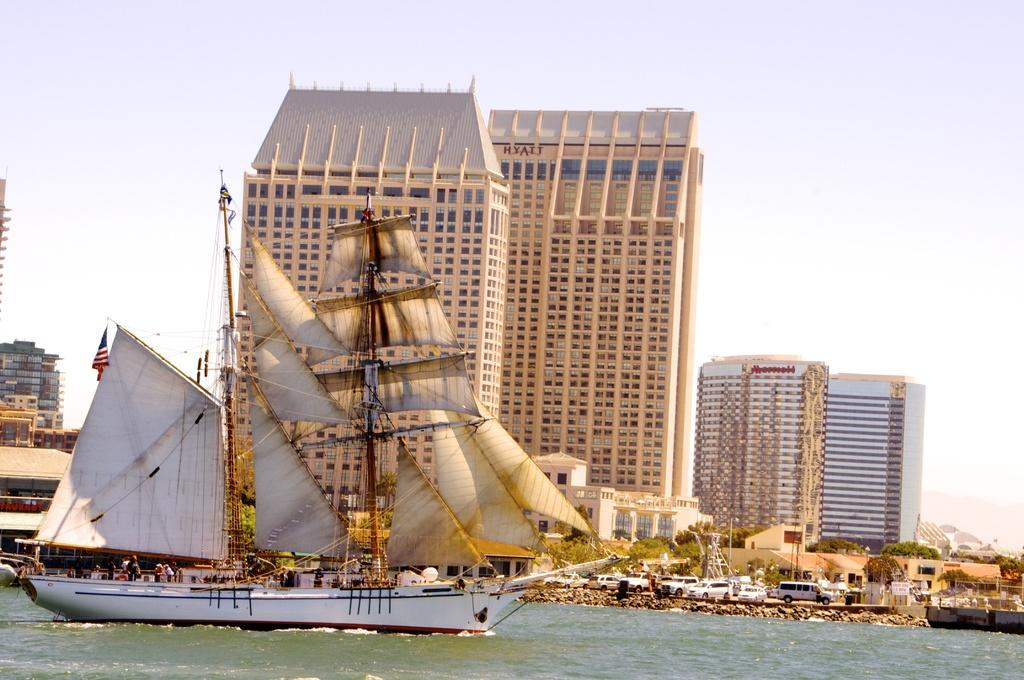What is in the front of the image? There is water in the front of the image. What is on the water? There is a ship on the water. What can be seen in the background of the image? There are vehicles, trees, buildings, and the sky visible in the background of the image. What type of rake is being used by the manager's daughter in the image? There is no rake, manager, or daughter present in the image. 